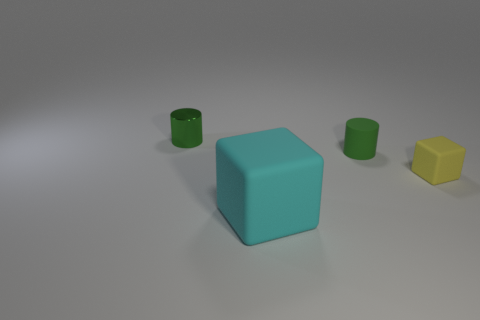Add 2 yellow matte things. How many objects exist? 6 Subtract all cyan blocks. How many blocks are left? 1 Subtract 2 blocks. How many blocks are left? 0 Subtract all purple cylinders. Subtract all blue blocks. How many cylinders are left? 2 Subtract all small gray blocks. Subtract all large cyan blocks. How many objects are left? 3 Add 4 yellow rubber objects. How many yellow rubber objects are left? 5 Add 2 large gray metal cylinders. How many large gray metal cylinders exist? 2 Subtract 0 yellow spheres. How many objects are left? 4 